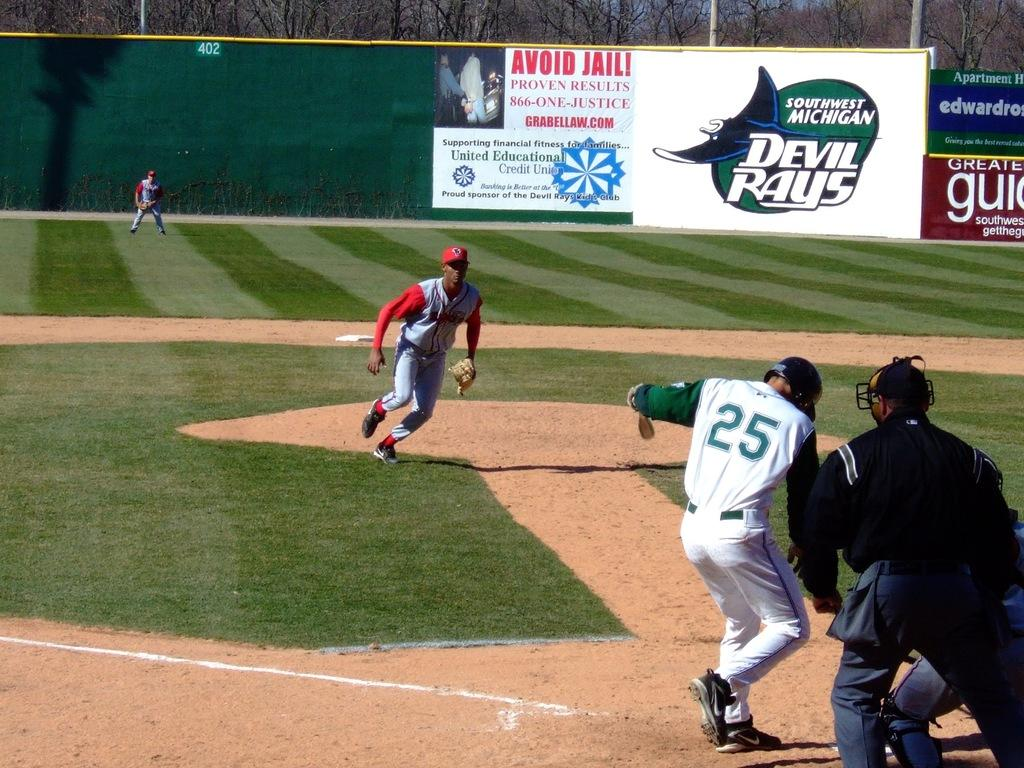<image>
Present a compact description of the photo's key features. Player number 25 is coming in to home plate in this baseball game. 